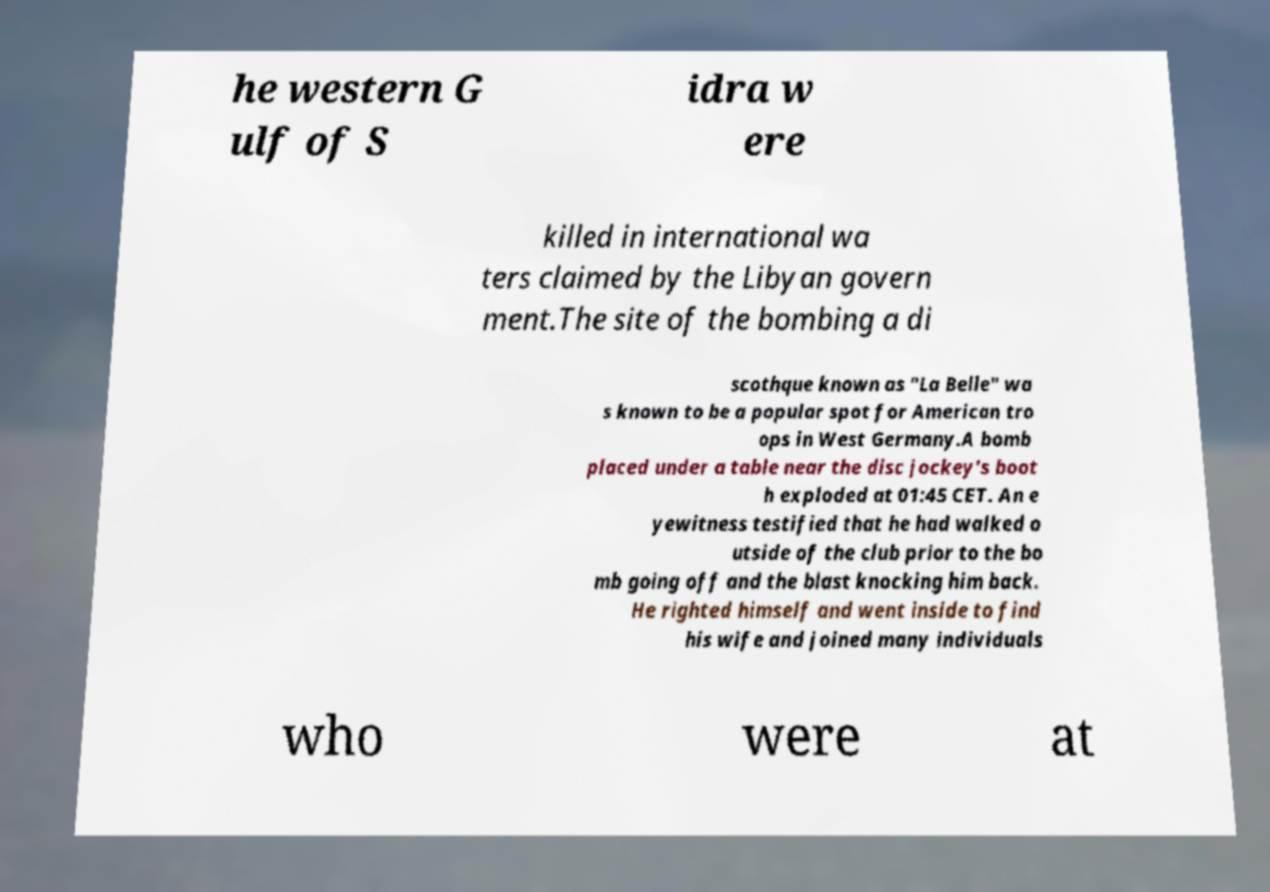There's text embedded in this image that I need extracted. Can you transcribe it verbatim? he western G ulf of S idra w ere killed in international wa ters claimed by the Libyan govern ment.The site of the bombing a di scothque known as "La Belle" wa s known to be a popular spot for American tro ops in West Germany.A bomb placed under a table near the disc jockey's boot h exploded at 01:45 CET. An e yewitness testified that he had walked o utside of the club prior to the bo mb going off and the blast knocking him back. He righted himself and went inside to find his wife and joined many individuals who were at 